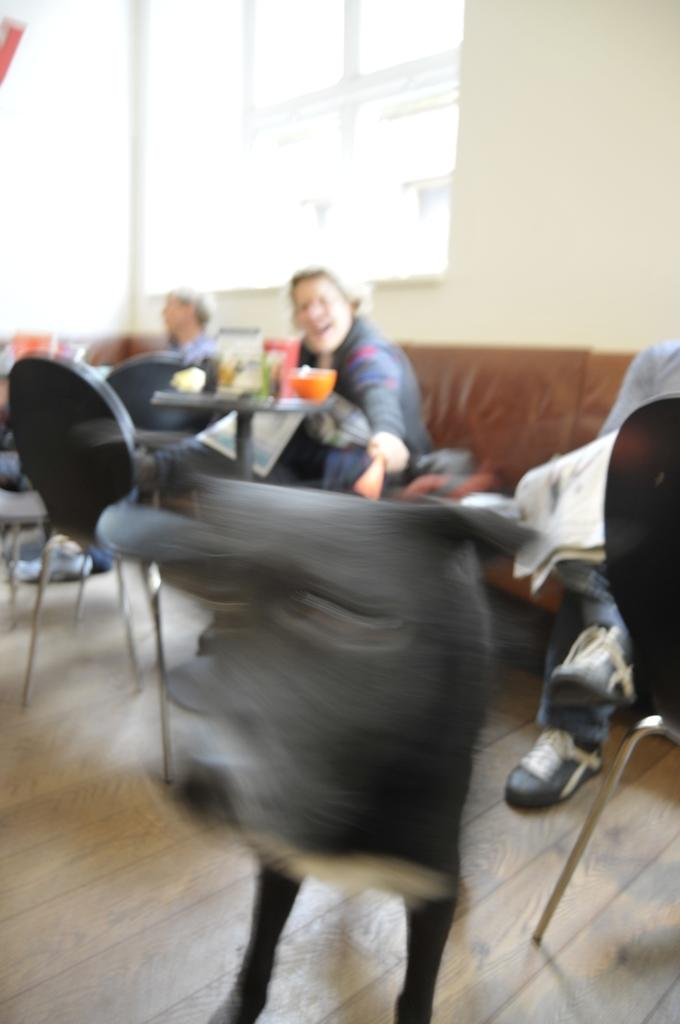Who is present in the image? There is a woman in the image. What is the woman doing in the image? The woman is sitting in chairs. Where are the chairs located in relation to the table? The chairs are in front of a table. What can be seen in the background of the image? There is a window and a wall in the background of the image. What flavor of toothpaste does the woman use in the image? There is no toothpaste present in the image, and therefore no information about the flavor can be provided. 